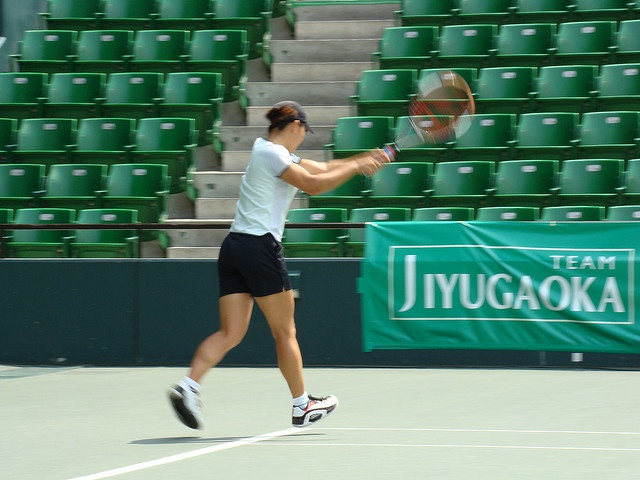Describe the objects in this image and their specific colors. I can see chair in black, darkgreen, and teal tones, people in black, gray, darkgray, and lightgray tones, tennis racket in black, gray, darkgray, and maroon tones, chair in black, darkgreen, and teal tones, and chair in black, darkgreen, and teal tones in this image. 